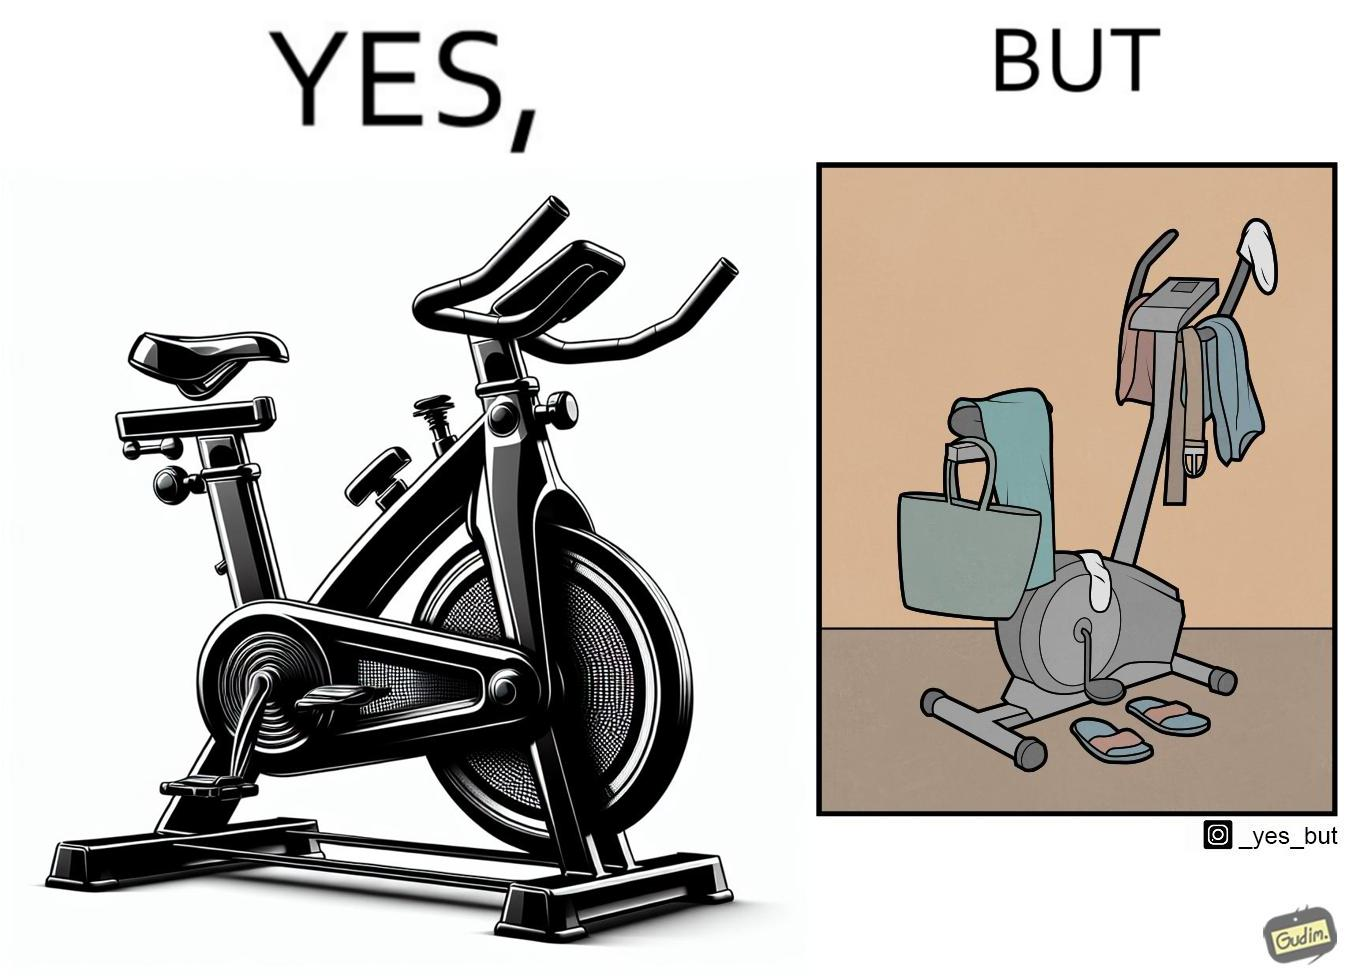Explain the humor or irony in this image. The images are funny since they show an exercise bike has been bought but is not being used for its purpose, that is, exercising. It is rather being used to hang clothes, bags and other items 